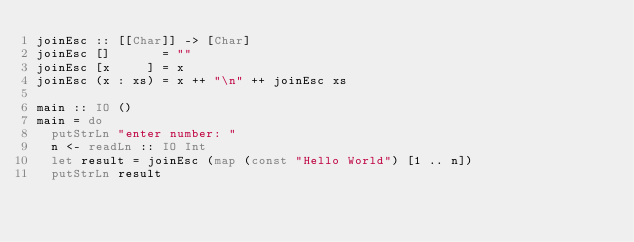Convert code to text. <code><loc_0><loc_0><loc_500><loc_500><_Haskell_>joinEsc :: [[Char]] -> [Char]
joinEsc []       = ""
joinEsc [x     ] = x
joinEsc (x : xs) = x ++ "\n" ++ joinEsc xs

main :: IO ()
main = do
  putStrLn "enter number: "
  n <- readLn :: IO Int
  let result = joinEsc (map (const "Hello World") [1 .. n])
  putStrLn result
</code> 